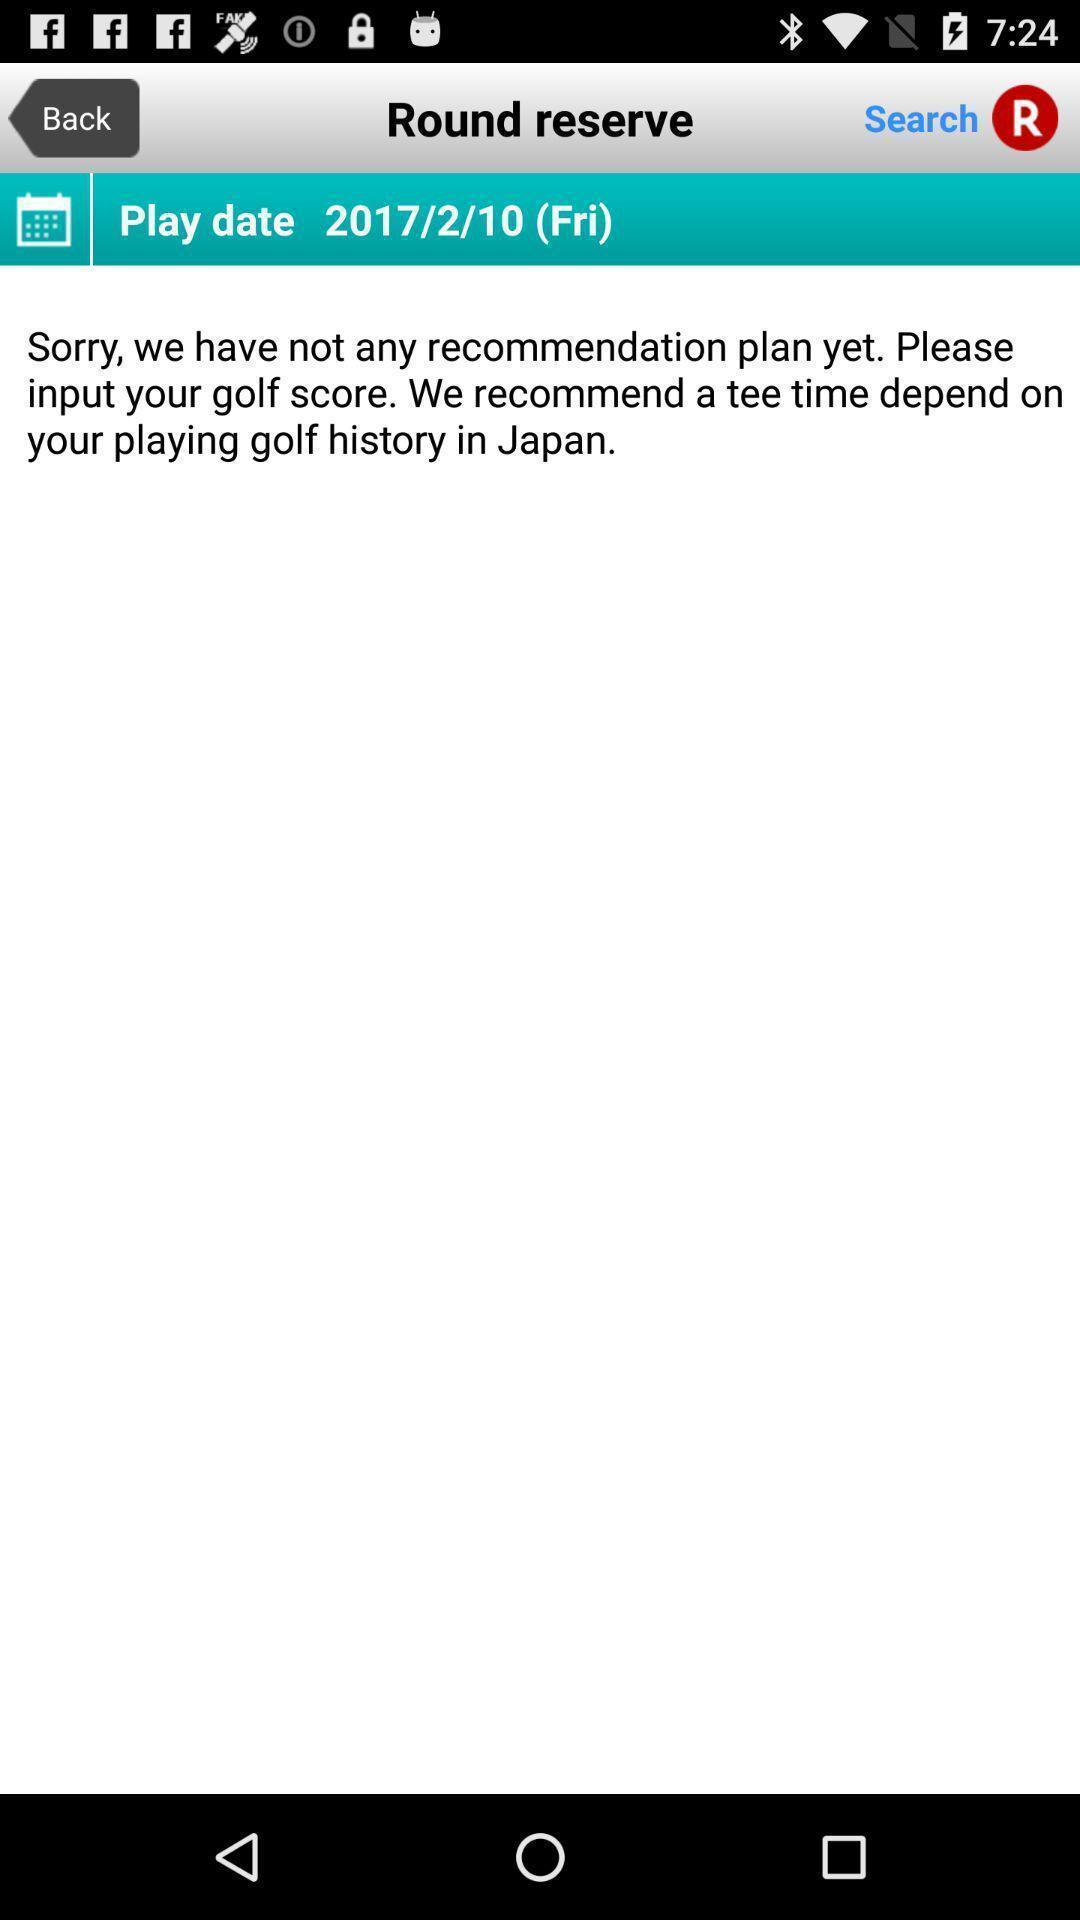Provide a textual representation of this image. Screen shows round reserver details in a sports app. 